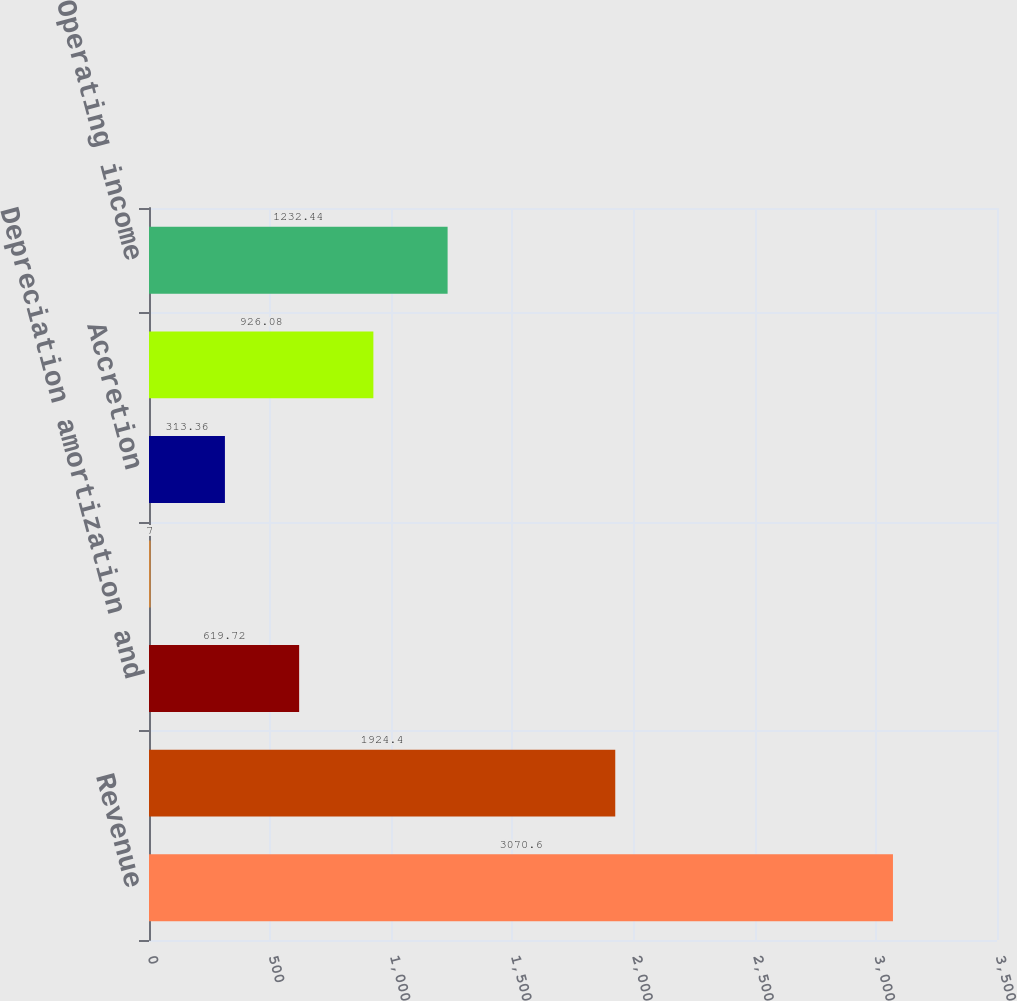Convert chart. <chart><loc_0><loc_0><loc_500><loc_500><bar_chart><fcel>Revenue<fcel>Cost of operations<fcel>Depreciation amortization and<fcel>Amortization of intangible<fcel>Accretion<fcel>Selling general and<fcel>Operating income<nl><fcel>3070.6<fcel>1924.4<fcel>619.72<fcel>7<fcel>313.36<fcel>926.08<fcel>1232.44<nl></chart> 